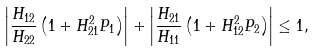Convert formula to latex. <formula><loc_0><loc_0><loc_500><loc_500>\left | \frac { H _ { 1 2 } } { H _ { 2 2 } } \left ( 1 + H _ { 2 1 } ^ { 2 } P _ { 1 } \right ) \right | + \left | \frac { H _ { 2 1 } } { H _ { 1 1 } } \left ( 1 + H _ { 1 2 } ^ { 2 } P _ { 2 } \right ) \right | \leq 1 ,</formula> 